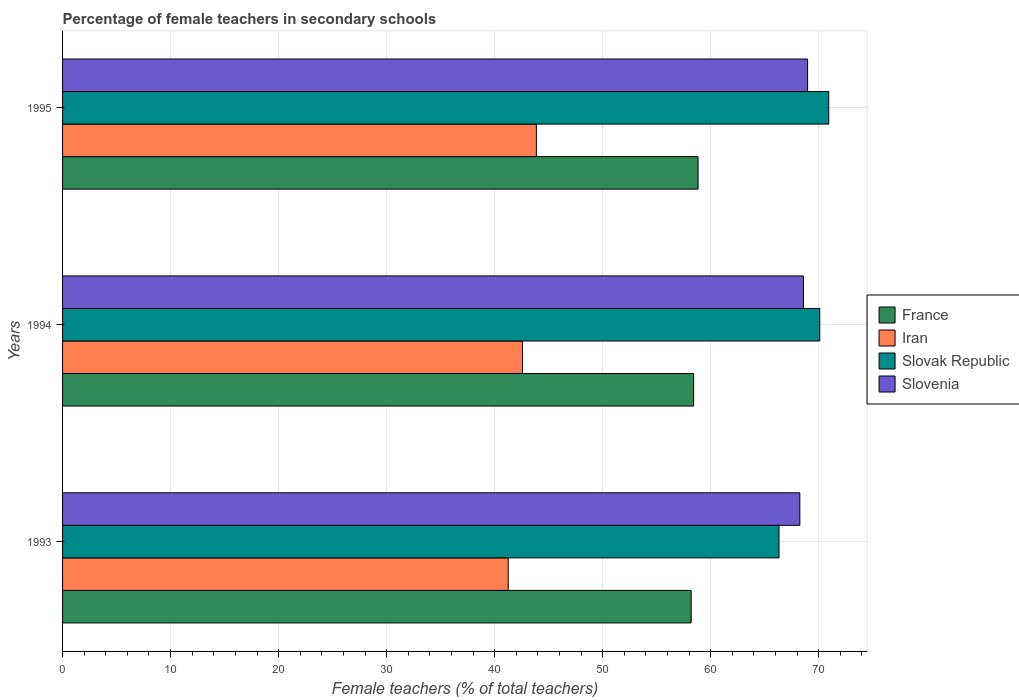How many groups of bars are there?
Your response must be concise. 3. Are the number of bars per tick equal to the number of legend labels?
Your response must be concise. Yes. How many bars are there on the 2nd tick from the bottom?
Provide a short and direct response. 4. What is the label of the 3rd group of bars from the top?
Provide a succinct answer. 1993. In how many cases, is the number of bars for a given year not equal to the number of legend labels?
Your response must be concise. 0. What is the percentage of female teachers in Iran in 1994?
Your answer should be very brief. 42.58. Across all years, what is the maximum percentage of female teachers in Iran?
Your response must be concise. 43.86. Across all years, what is the minimum percentage of female teachers in Slovak Republic?
Your response must be concise. 66.32. In which year was the percentage of female teachers in France maximum?
Provide a succinct answer. 1995. What is the total percentage of female teachers in France in the graph?
Provide a short and direct response. 175.45. What is the difference between the percentage of female teachers in France in 1993 and that in 1994?
Your answer should be compact. -0.23. What is the difference between the percentage of female teachers in Iran in 1993 and the percentage of female teachers in Slovak Republic in 1995?
Offer a very short reply. -29.68. What is the average percentage of female teachers in Slovak Republic per year?
Ensure brevity in your answer.  69.12. In the year 1995, what is the difference between the percentage of female teachers in Slovenia and percentage of female teachers in France?
Ensure brevity in your answer.  10.14. What is the ratio of the percentage of female teachers in France in 1994 to that in 1995?
Provide a succinct answer. 0.99. Is the percentage of female teachers in Iran in 1994 less than that in 1995?
Make the answer very short. Yes. Is the difference between the percentage of female teachers in Slovenia in 1993 and 1995 greater than the difference between the percentage of female teachers in France in 1993 and 1995?
Offer a very short reply. No. What is the difference between the highest and the second highest percentage of female teachers in Iran?
Give a very brief answer. 1.29. What is the difference between the highest and the lowest percentage of female teachers in Slovenia?
Provide a short and direct response. 0.72. In how many years, is the percentage of female teachers in France greater than the average percentage of female teachers in France taken over all years?
Give a very brief answer. 1. What does the 2nd bar from the bottom in 1995 represents?
Ensure brevity in your answer.  Iran. Are all the bars in the graph horizontal?
Your answer should be compact. Yes. How many years are there in the graph?
Make the answer very short. 3. Are the values on the major ticks of X-axis written in scientific E-notation?
Ensure brevity in your answer.  No. Does the graph contain any zero values?
Offer a terse response. No. Where does the legend appear in the graph?
Your answer should be very brief. Center right. What is the title of the graph?
Provide a succinct answer. Percentage of female teachers in secondary schools. What is the label or title of the X-axis?
Your answer should be compact. Female teachers (% of total teachers). What is the label or title of the Y-axis?
Give a very brief answer. Years. What is the Female teachers (% of total teachers) of France in 1993?
Give a very brief answer. 58.19. What is the Female teachers (% of total teachers) in Iran in 1993?
Your response must be concise. 41.25. What is the Female teachers (% of total teachers) in Slovak Republic in 1993?
Your answer should be compact. 66.32. What is the Female teachers (% of total teachers) of Slovenia in 1993?
Your response must be concise. 68.25. What is the Female teachers (% of total teachers) in France in 1994?
Your answer should be very brief. 58.42. What is the Female teachers (% of total teachers) of Iran in 1994?
Your answer should be compact. 42.58. What is the Female teachers (% of total teachers) of Slovak Republic in 1994?
Offer a very short reply. 70.1. What is the Female teachers (% of total teachers) of Slovenia in 1994?
Offer a terse response. 68.59. What is the Female teachers (% of total teachers) in France in 1995?
Give a very brief answer. 58.83. What is the Female teachers (% of total teachers) of Iran in 1995?
Offer a very short reply. 43.86. What is the Female teachers (% of total teachers) of Slovak Republic in 1995?
Provide a succinct answer. 70.93. What is the Female teachers (% of total teachers) of Slovenia in 1995?
Provide a short and direct response. 68.97. Across all years, what is the maximum Female teachers (% of total teachers) of France?
Offer a very short reply. 58.83. Across all years, what is the maximum Female teachers (% of total teachers) in Iran?
Keep it short and to the point. 43.86. Across all years, what is the maximum Female teachers (% of total teachers) in Slovak Republic?
Your answer should be very brief. 70.93. Across all years, what is the maximum Female teachers (% of total teachers) of Slovenia?
Your response must be concise. 68.97. Across all years, what is the minimum Female teachers (% of total teachers) of France?
Provide a succinct answer. 58.19. Across all years, what is the minimum Female teachers (% of total teachers) of Iran?
Ensure brevity in your answer.  41.25. Across all years, what is the minimum Female teachers (% of total teachers) in Slovak Republic?
Your answer should be very brief. 66.32. Across all years, what is the minimum Female teachers (% of total teachers) in Slovenia?
Make the answer very short. 68.25. What is the total Female teachers (% of total teachers) of France in the graph?
Offer a very short reply. 175.45. What is the total Female teachers (% of total teachers) of Iran in the graph?
Your answer should be very brief. 127.69. What is the total Female teachers (% of total teachers) of Slovak Republic in the graph?
Keep it short and to the point. 207.35. What is the total Female teachers (% of total teachers) in Slovenia in the graph?
Offer a very short reply. 205.81. What is the difference between the Female teachers (% of total teachers) in France in 1993 and that in 1994?
Offer a very short reply. -0.23. What is the difference between the Female teachers (% of total teachers) of Iran in 1993 and that in 1994?
Your answer should be very brief. -1.32. What is the difference between the Female teachers (% of total teachers) in Slovak Republic in 1993 and that in 1994?
Keep it short and to the point. -3.77. What is the difference between the Female teachers (% of total teachers) of Slovenia in 1993 and that in 1994?
Provide a succinct answer. -0.33. What is the difference between the Female teachers (% of total teachers) in France in 1993 and that in 1995?
Your answer should be very brief. -0.64. What is the difference between the Female teachers (% of total teachers) in Iran in 1993 and that in 1995?
Make the answer very short. -2.61. What is the difference between the Female teachers (% of total teachers) in Slovak Republic in 1993 and that in 1995?
Keep it short and to the point. -4.61. What is the difference between the Female teachers (% of total teachers) of Slovenia in 1993 and that in 1995?
Provide a short and direct response. -0.72. What is the difference between the Female teachers (% of total teachers) in France in 1994 and that in 1995?
Ensure brevity in your answer.  -0.41. What is the difference between the Female teachers (% of total teachers) in Iran in 1994 and that in 1995?
Your response must be concise. -1.29. What is the difference between the Female teachers (% of total teachers) in Slovak Republic in 1994 and that in 1995?
Offer a very short reply. -0.83. What is the difference between the Female teachers (% of total teachers) of Slovenia in 1994 and that in 1995?
Your answer should be compact. -0.39. What is the difference between the Female teachers (% of total teachers) of France in 1993 and the Female teachers (% of total teachers) of Iran in 1994?
Your answer should be compact. 15.62. What is the difference between the Female teachers (% of total teachers) of France in 1993 and the Female teachers (% of total teachers) of Slovak Republic in 1994?
Your answer should be compact. -11.9. What is the difference between the Female teachers (% of total teachers) of France in 1993 and the Female teachers (% of total teachers) of Slovenia in 1994?
Give a very brief answer. -10.39. What is the difference between the Female teachers (% of total teachers) of Iran in 1993 and the Female teachers (% of total teachers) of Slovak Republic in 1994?
Offer a very short reply. -28.84. What is the difference between the Female teachers (% of total teachers) in Iran in 1993 and the Female teachers (% of total teachers) in Slovenia in 1994?
Your answer should be compact. -27.33. What is the difference between the Female teachers (% of total teachers) of Slovak Republic in 1993 and the Female teachers (% of total teachers) of Slovenia in 1994?
Give a very brief answer. -2.26. What is the difference between the Female teachers (% of total teachers) of France in 1993 and the Female teachers (% of total teachers) of Iran in 1995?
Offer a terse response. 14.33. What is the difference between the Female teachers (% of total teachers) of France in 1993 and the Female teachers (% of total teachers) of Slovak Republic in 1995?
Provide a succinct answer. -12.73. What is the difference between the Female teachers (% of total teachers) of France in 1993 and the Female teachers (% of total teachers) of Slovenia in 1995?
Your answer should be compact. -10.78. What is the difference between the Female teachers (% of total teachers) of Iran in 1993 and the Female teachers (% of total teachers) of Slovak Republic in 1995?
Give a very brief answer. -29.68. What is the difference between the Female teachers (% of total teachers) in Iran in 1993 and the Female teachers (% of total teachers) in Slovenia in 1995?
Your response must be concise. -27.72. What is the difference between the Female teachers (% of total teachers) of Slovak Republic in 1993 and the Female teachers (% of total teachers) of Slovenia in 1995?
Offer a very short reply. -2.65. What is the difference between the Female teachers (% of total teachers) in France in 1994 and the Female teachers (% of total teachers) in Iran in 1995?
Give a very brief answer. 14.56. What is the difference between the Female teachers (% of total teachers) of France in 1994 and the Female teachers (% of total teachers) of Slovak Republic in 1995?
Your response must be concise. -12.51. What is the difference between the Female teachers (% of total teachers) in France in 1994 and the Female teachers (% of total teachers) in Slovenia in 1995?
Your answer should be very brief. -10.55. What is the difference between the Female teachers (% of total teachers) of Iran in 1994 and the Female teachers (% of total teachers) of Slovak Republic in 1995?
Ensure brevity in your answer.  -28.35. What is the difference between the Female teachers (% of total teachers) in Iran in 1994 and the Female teachers (% of total teachers) in Slovenia in 1995?
Your answer should be compact. -26.39. What is the difference between the Female teachers (% of total teachers) in Slovak Republic in 1994 and the Female teachers (% of total teachers) in Slovenia in 1995?
Provide a short and direct response. 1.13. What is the average Female teachers (% of total teachers) of France per year?
Keep it short and to the point. 58.48. What is the average Female teachers (% of total teachers) in Iran per year?
Your response must be concise. 42.56. What is the average Female teachers (% of total teachers) of Slovak Republic per year?
Give a very brief answer. 69.12. What is the average Female teachers (% of total teachers) of Slovenia per year?
Keep it short and to the point. 68.6. In the year 1993, what is the difference between the Female teachers (% of total teachers) in France and Female teachers (% of total teachers) in Iran?
Your response must be concise. 16.94. In the year 1993, what is the difference between the Female teachers (% of total teachers) of France and Female teachers (% of total teachers) of Slovak Republic?
Offer a very short reply. -8.13. In the year 1993, what is the difference between the Female teachers (% of total teachers) in France and Female teachers (% of total teachers) in Slovenia?
Provide a short and direct response. -10.06. In the year 1993, what is the difference between the Female teachers (% of total teachers) of Iran and Female teachers (% of total teachers) of Slovak Republic?
Keep it short and to the point. -25.07. In the year 1993, what is the difference between the Female teachers (% of total teachers) of Iran and Female teachers (% of total teachers) of Slovenia?
Ensure brevity in your answer.  -27. In the year 1993, what is the difference between the Female teachers (% of total teachers) in Slovak Republic and Female teachers (% of total teachers) in Slovenia?
Your response must be concise. -1.93. In the year 1994, what is the difference between the Female teachers (% of total teachers) in France and Female teachers (% of total teachers) in Iran?
Your answer should be very brief. 15.84. In the year 1994, what is the difference between the Female teachers (% of total teachers) of France and Female teachers (% of total teachers) of Slovak Republic?
Provide a succinct answer. -11.68. In the year 1994, what is the difference between the Female teachers (% of total teachers) of France and Female teachers (% of total teachers) of Slovenia?
Provide a short and direct response. -10.17. In the year 1994, what is the difference between the Female teachers (% of total teachers) in Iran and Female teachers (% of total teachers) in Slovak Republic?
Your answer should be compact. -27.52. In the year 1994, what is the difference between the Female teachers (% of total teachers) of Iran and Female teachers (% of total teachers) of Slovenia?
Provide a short and direct response. -26.01. In the year 1994, what is the difference between the Female teachers (% of total teachers) in Slovak Republic and Female teachers (% of total teachers) in Slovenia?
Provide a succinct answer. 1.51. In the year 1995, what is the difference between the Female teachers (% of total teachers) in France and Female teachers (% of total teachers) in Iran?
Provide a succinct answer. 14.97. In the year 1995, what is the difference between the Female teachers (% of total teachers) in France and Female teachers (% of total teachers) in Slovak Republic?
Your response must be concise. -12.1. In the year 1995, what is the difference between the Female teachers (% of total teachers) in France and Female teachers (% of total teachers) in Slovenia?
Give a very brief answer. -10.14. In the year 1995, what is the difference between the Female teachers (% of total teachers) in Iran and Female teachers (% of total teachers) in Slovak Republic?
Offer a terse response. -27.07. In the year 1995, what is the difference between the Female teachers (% of total teachers) in Iran and Female teachers (% of total teachers) in Slovenia?
Give a very brief answer. -25.11. In the year 1995, what is the difference between the Female teachers (% of total teachers) in Slovak Republic and Female teachers (% of total teachers) in Slovenia?
Offer a terse response. 1.96. What is the ratio of the Female teachers (% of total teachers) in Iran in 1993 to that in 1994?
Ensure brevity in your answer.  0.97. What is the ratio of the Female teachers (% of total teachers) of Slovak Republic in 1993 to that in 1994?
Ensure brevity in your answer.  0.95. What is the ratio of the Female teachers (% of total teachers) in Iran in 1993 to that in 1995?
Keep it short and to the point. 0.94. What is the ratio of the Female teachers (% of total teachers) of Slovak Republic in 1993 to that in 1995?
Your response must be concise. 0.94. What is the ratio of the Female teachers (% of total teachers) of Slovenia in 1993 to that in 1995?
Make the answer very short. 0.99. What is the ratio of the Female teachers (% of total teachers) of France in 1994 to that in 1995?
Your answer should be very brief. 0.99. What is the ratio of the Female teachers (% of total teachers) in Iran in 1994 to that in 1995?
Ensure brevity in your answer.  0.97. What is the ratio of the Female teachers (% of total teachers) in Slovak Republic in 1994 to that in 1995?
Offer a terse response. 0.99. What is the ratio of the Female teachers (% of total teachers) of Slovenia in 1994 to that in 1995?
Make the answer very short. 0.99. What is the difference between the highest and the second highest Female teachers (% of total teachers) of France?
Keep it short and to the point. 0.41. What is the difference between the highest and the second highest Female teachers (% of total teachers) of Iran?
Provide a succinct answer. 1.29. What is the difference between the highest and the second highest Female teachers (% of total teachers) in Slovak Republic?
Your response must be concise. 0.83. What is the difference between the highest and the second highest Female teachers (% of total teachers) of Slovenia?
Make the answer very short. 0.39. What is the difference between the highest and the lowest Female teachers (% of total teachers) in France?
Make the answer very short. 0.64. What is the difference between the highest and the lowest Female teachers (% of total teachers) of Iran?
Offer a terse response. 2.61. What is the difference between the highest and the lowest Female teachers (% of total teachers) in Slovak Republic?
Offer a terse response. 4.61. What is the difference between the highest and the lowest Female teachers (% of total teachers) in Slovenia?
Give a very brief answer. 0.72. 